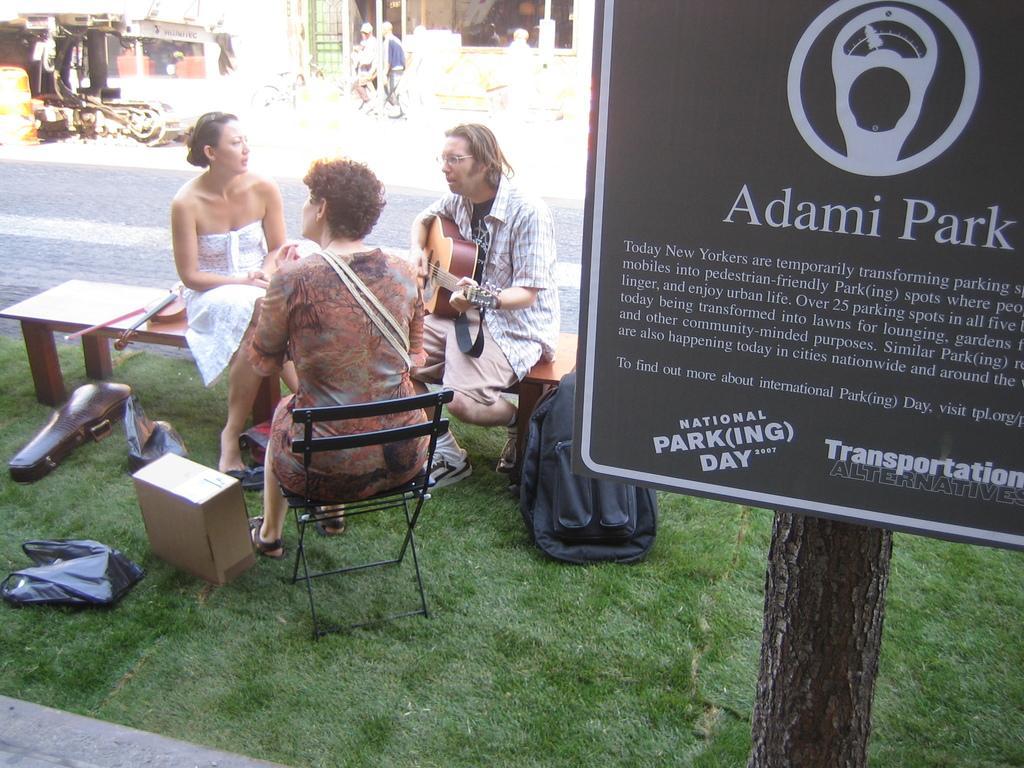Could you give a brief overview of what you see in this image? In this image there is a woman sitting on the chair, there is a woman sitting on the bench, there is a man sitting on the bench, he is playing a musical instrument, there is a musical instrument on the bench, there is grass towards the bottom of the image, there are objects on the grass, there is a tree trunk towards the bottom of the image, there is a board towards the right of the image, there is text on the board, there is a road, there is an object towards the left of the image, there are buildings towards the top of the image, there are two persons on the road. 